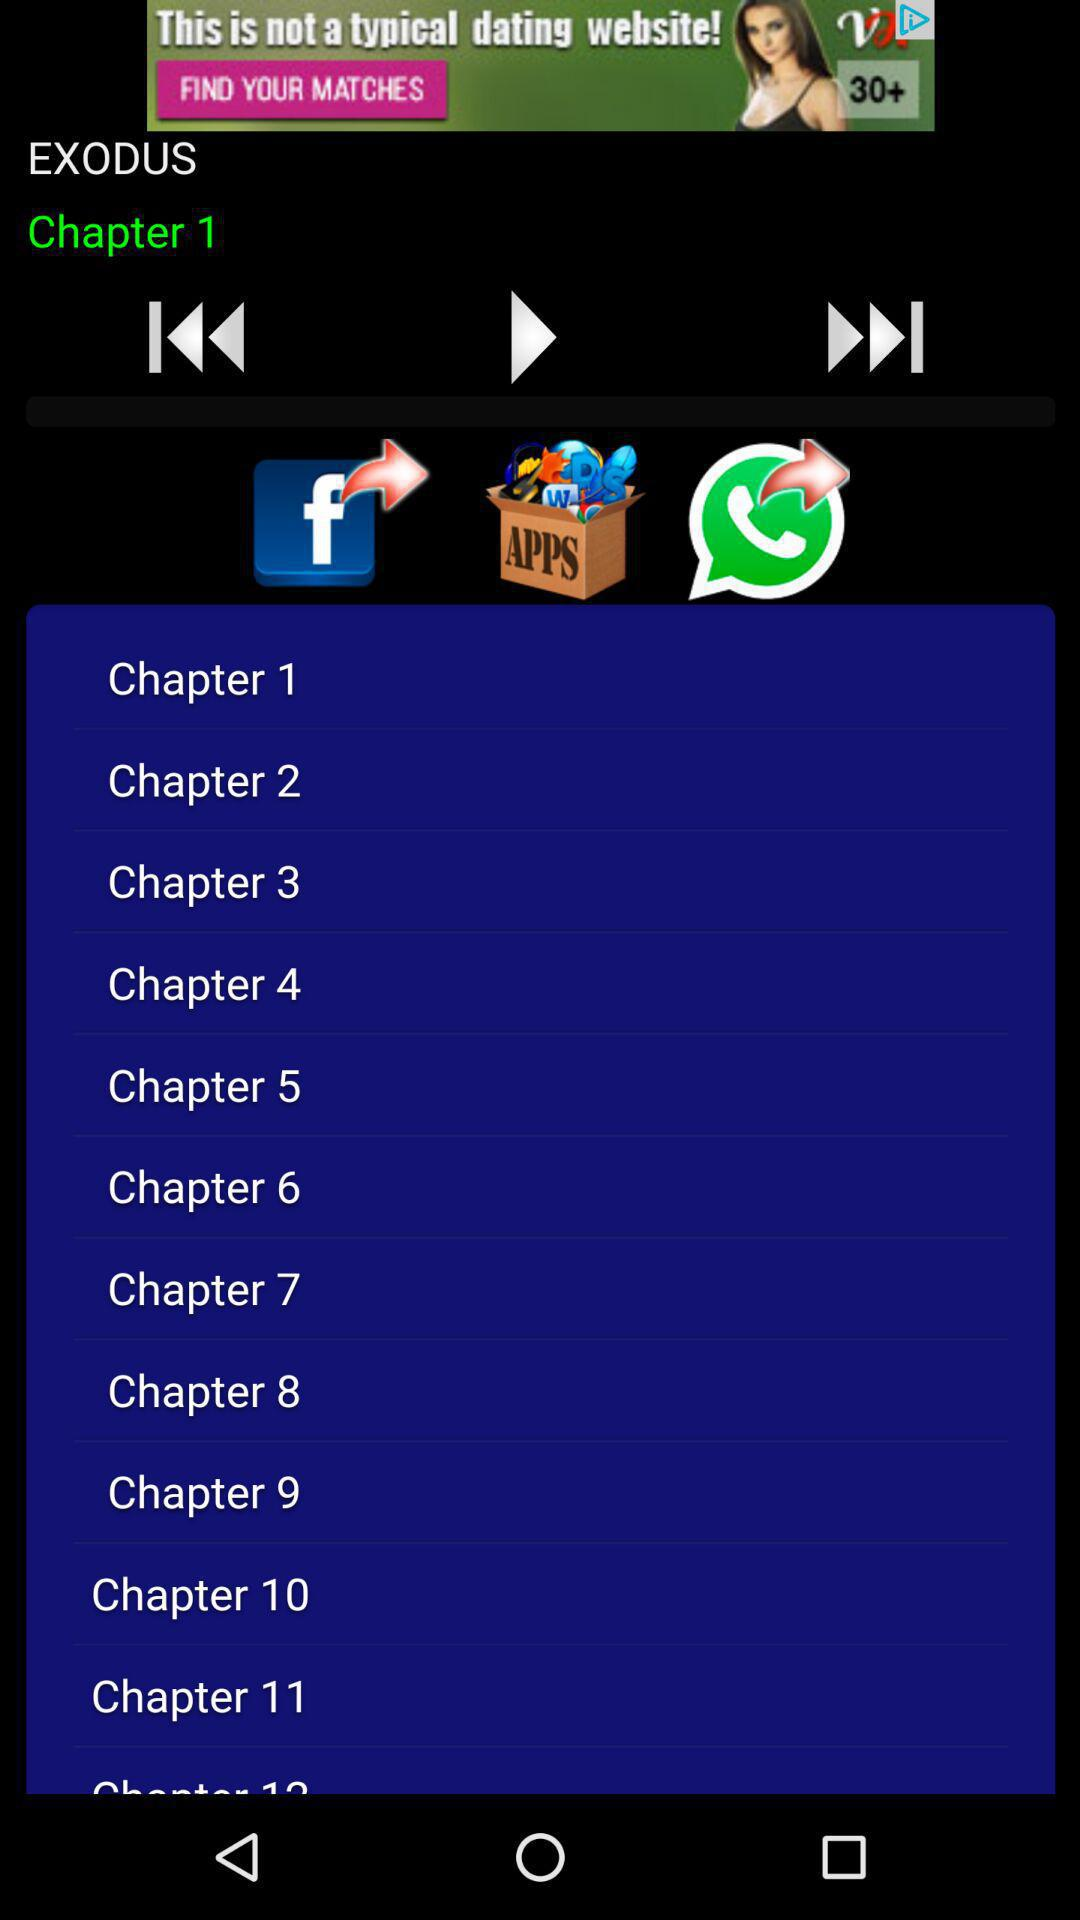Which application can be used to share the chapters? The applications "Facebook" and "Whatsapp" can be used to share the chapters. 